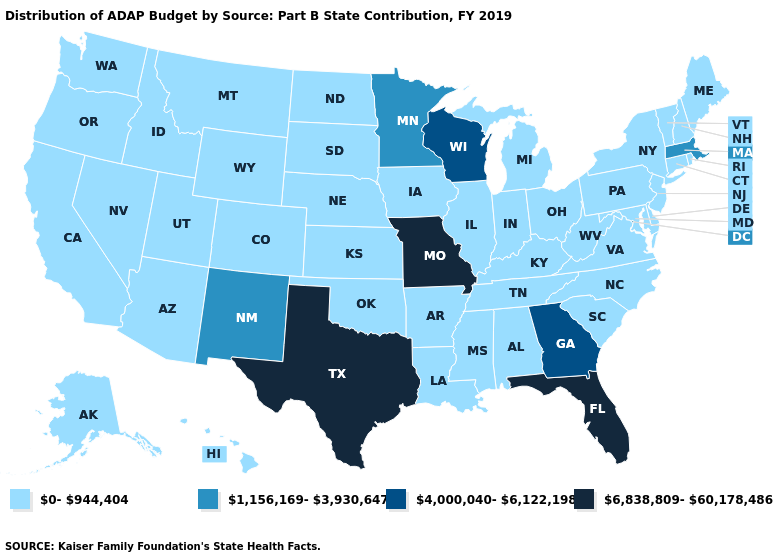What is the lowest value in the South?
Quick response, please. 0-944,404. Which states have the lowest value in the USA?
Quick response, please. Alabama, Alaska, Arizona, Arkansas, California, Colorado, Connecticut, Delaware, Hawaii, Idaho, Illinois, Indiana, Iowa, Kansas, Kentucky, Louisiana, Maine, Maryland, Michigan, Mississippi, Montana, Nebraska, Nevada, New Hampshire, New Jersey, New York, North Carolina, North Dakota, Ohio, Oklahoma, Oregon, Pennsylvania, Rhode Island, South Carolina, South Dakota, Tennessee, Utah, Vermont, Virginia, Washington, West Virginia, Wyoming. What is the highest value in the USA?
Concise answer only. 6,838,809-60,178,486. How many symbols are there in the legend?
Write a very short answer. 4. Name the states that have a value in the range 6,838,809-60,178,486?
Be succinct. Florida, Missouri, Texas. Name the states that have a value in the range 0-944,404?
Concise answer only. Alabama, Alaska, Arizona, Arkansas, California, Colorado, Connecticut, Delaware, Hawaii, Idaho, Illinois, Indiana, Iowa, Kansas, Kentucky, Louisiana, Maine, Maryland, Michigan, Mississippi, Montana, Nebraska, Nevada, New Hampshire, New Jersey, New York, North Carolina, North Dakota, Ohio, Oklahoma, Oregon, Pennsylvania, Rhode Island, South Carolina, South Dakota, Tennessee, Utah, Vermont, Virginia, Washington, West Virginia, Wyoming. What is the highest value in the USA?
Short answer required. 6,838,809-60,178,486. How many symbols are there in the legend?
Keep it brief. 4. What is the lowest value in the MidWest?
Keep it brief. 0-944,404. What is the value of New Mexico?
Be succinct. 1,156,169-3,930,647. Does Illinois have the lowest value in the MidWest?
Write a very short answer. Yes. How many symbols are there in the legend?
Write a very short answer. 4. What is the value of Pennsylvania?
Short answer required. 0-944,404. Name the states that have a value in the range 1,156,169-3,930,647?
Keep it brief. Massachusetts, Minnesota, New Mexico. 